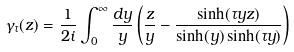<formula> <loc_0><loc_0><loc_500><loc_500>\gamma _ { \tau } ( z ) = \frac { 1 } { 2 i } \int _ { 0 } ^ { \infty } \frac { d y } { y } \left ( \frac { z } { y } - \frac { \sinh ( \tau y z ) } { \sinh ( y ) \sinh ( \tau y ) } \right )</formula> 